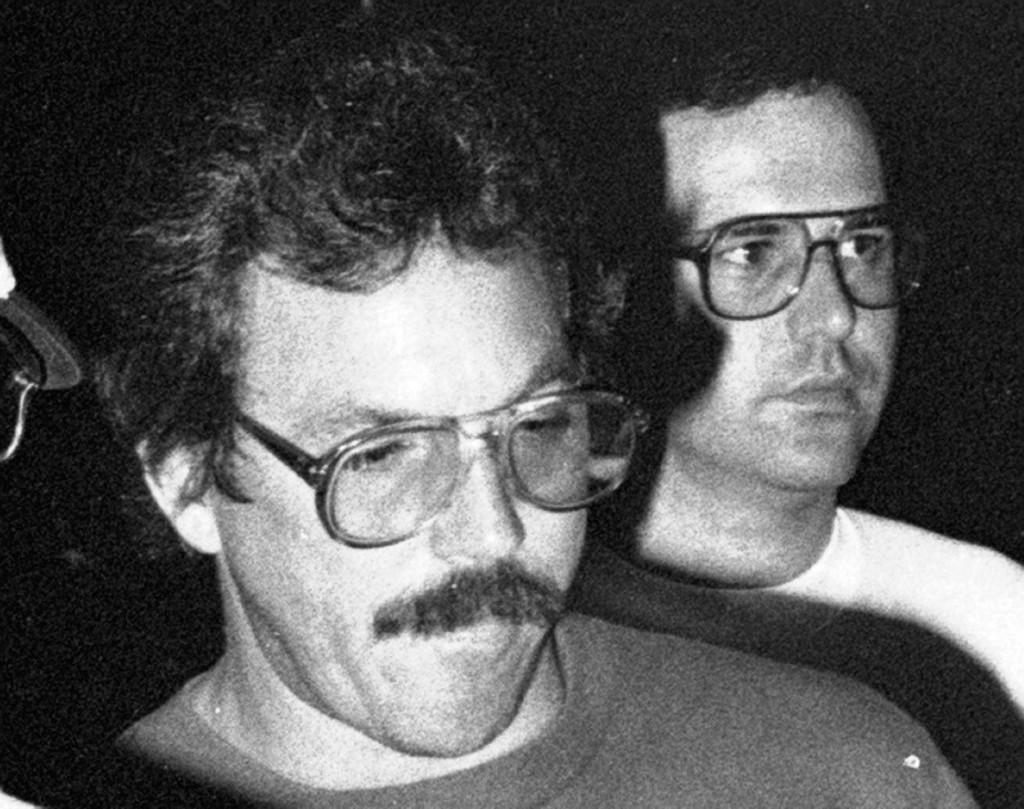In one or two sentences, can you explain what this image depicts? In this black and white image there are two persons standing. On the left side of the image we can see the specs of the other person. 